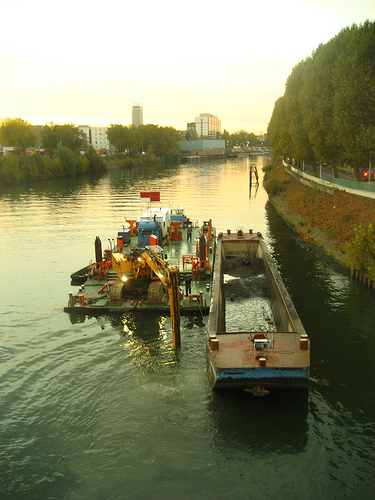<image>
Is there a bull dozer in the river? Yes. The bull dozer is contained within or inside the river, showing a containment relationship. 